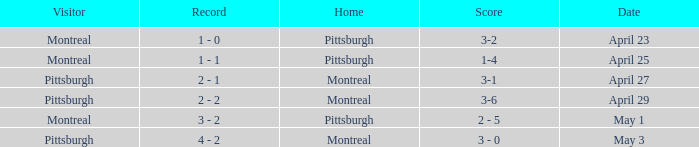What was the score on April 25? 1-4. 